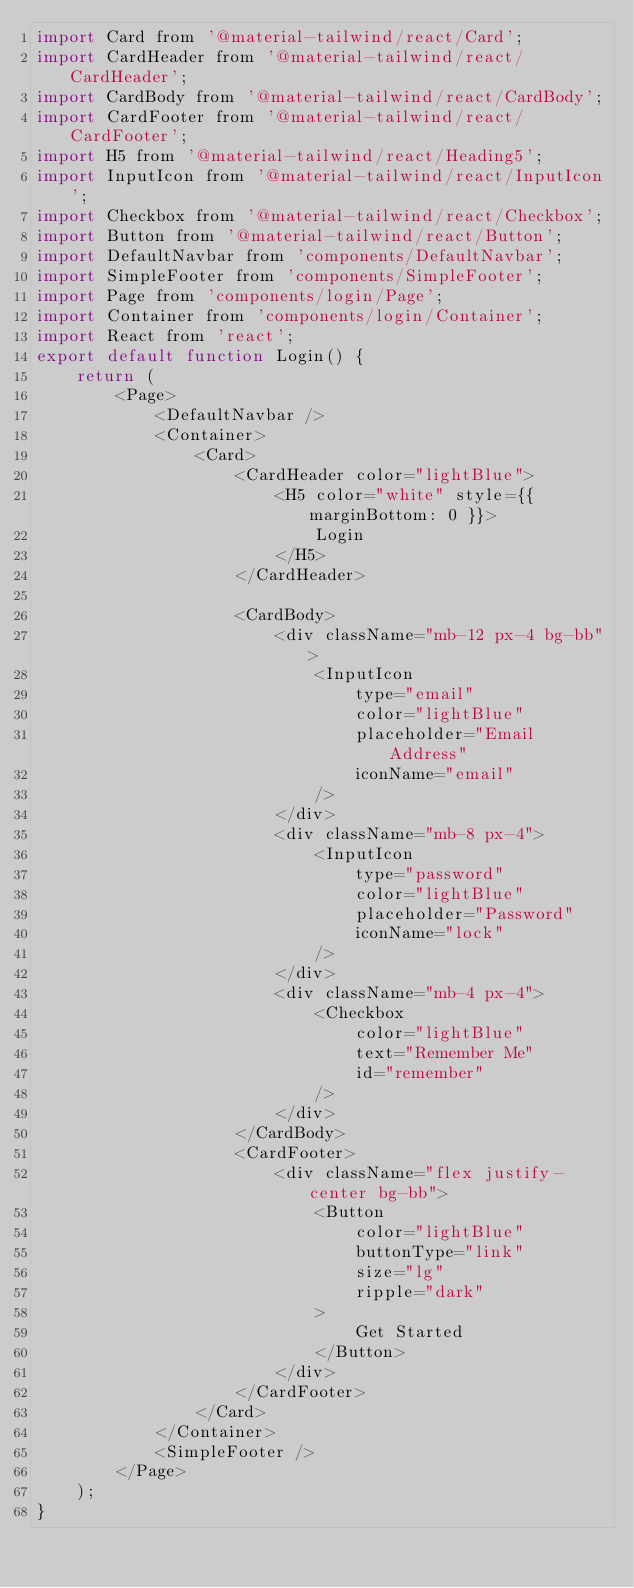<code> <loc_0><loc_0><loc_500><loc_500><_JavaScript_>import Card from '@material-tailwind/react/Card';
import CardHeader from '@material-tailwind/react/CardHeader';
import CardBody from '@material-tailwind/react/CardBody';
import CardFooter from '@material-tailwind/react/CardFooter';
import H5 from '@material-tailwind/react/Heading5';
import InputIcon from '@material-tailwind/react/InputIcon';
import Checkbox from '@material-tailwind/react/Checkbox';
import Button from '@material-tailwind/react/Button';
import DefaultNavbar from 'components/DefaultNavbar';
import SimpleFooter from 'components/SimpleFooter';
import Page from 'components/login/Page';
import Container from 'components/login/Container';
import React from 'react';
export default function Login() {
    return (
        <Page>
            <DefaultNavbar />
            <Container>
                <Card>
                    <CardHeader color="lightBlue">
                        <H5 color="white" style={{ marginBottom: 0 }}>
                            Login
                        </H5>
                    </CardHeader>

                    <CardBody>
                        <div className="mb-12 px-4 bg-bb">
                            <InputIcon
                                type="email"
                                color="lightBlue"
                                placeholder="Email Address"
                                iconName="email"
                            />
                        </div>
                        <div className="mb-8 px-4">
                            <InputIcon
                                type="password"
                                color="lightBlue"
                                placeholder="Password"
                                iconName="lock"
                            />
                        </div>
                        <div className="mb-4 px-4">
                            <Checkbox
                                color="lightBlue"
                                text="Remember Me"
                                id="remember"
                            />
                        </div>
                    </CardBody>
                    <CardFooter>
                        <div className="flex justify-center bg-bb">
                            <Button
                                color="lightBlue"
                                buttonType="link"
                                size="lg"
                                ripple="dark"
                            >
                                Get Started
                            </Button>
                        </div>
                    </CardFooter>
                </Card>
            </Container>
            <SimpleFooter />
        </Page>
    );
}
</code> 